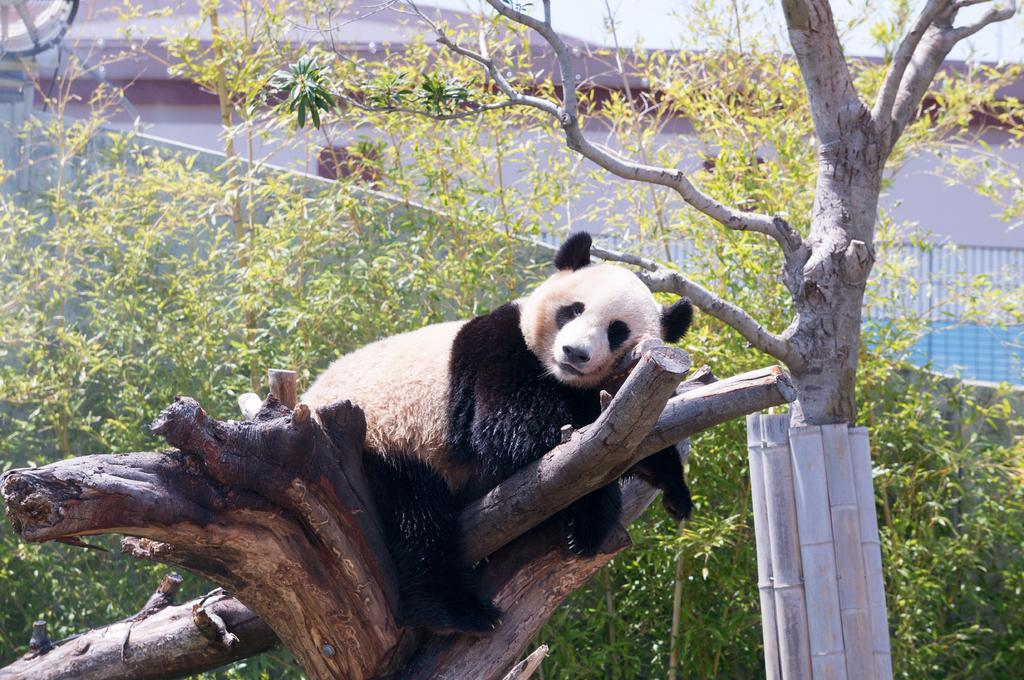What animal is featured in the image? There is a panda in the image. Where is the panda located? The panda is on a branch of a tree. What can be seen in the background of the image? There are plants in the background of the image. What is in front of the tree? Bamboo sticks are present in front of the tree. What type of punishment is the panda receiving in the image? There is no indication of punishment in the image; the panda is simply sitting on a branch of a tree. 